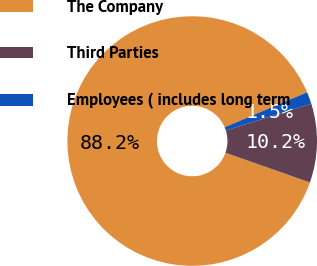Convert chart to OTSL. <chart><loc_0><loc_0><loc_500><loc_500><pie_chart><fcel>The Company<fcel>Third Parties<fcel>Employees ( includes long term<nl><fcel>88.23%<fcel>10.22%<fcel>1.55%<nl></chart> 